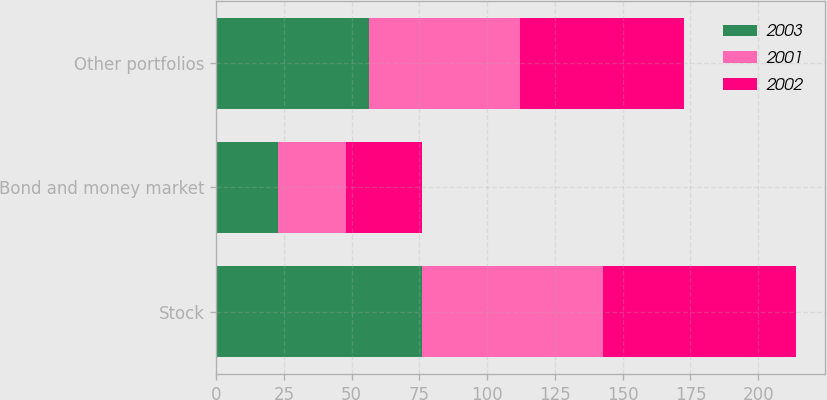Convert chart to OTSL. <chart><loc_0><loc_0><loc_500><loc_500><stacked_bar_chart><ecel><fcel>Stock<fcel>Bond and money market<fcel>Other portfolios<nl><fcel>2003<fcel>75.8<fcel>22.9<fcel>56.5<nl><fcel>2001<fcel>67.1<fcel>25<fcel>55.5<nl><fcel>2002<fcel>71.2<fcel>28.2<fcel>60.5<nl></chart> 